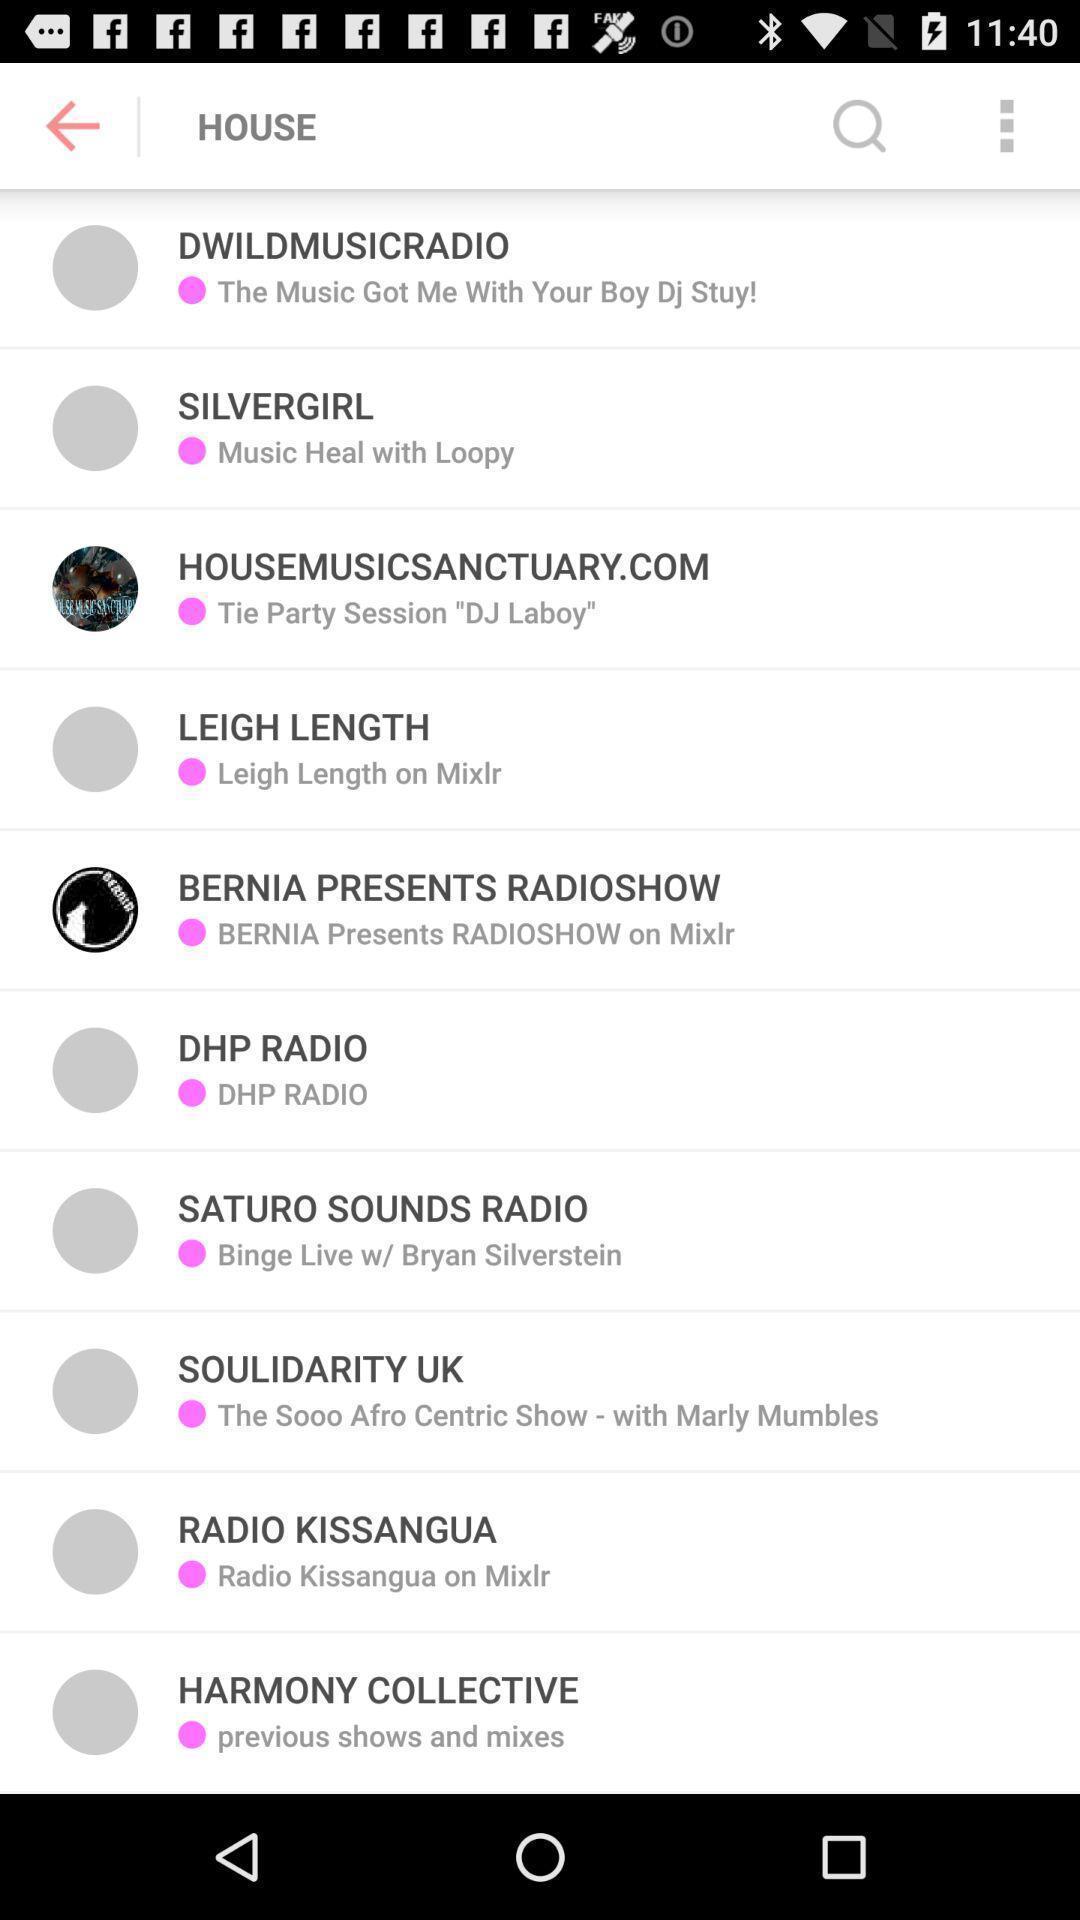Provide a detailed account of this screenshot. Page showing different option for search results. 